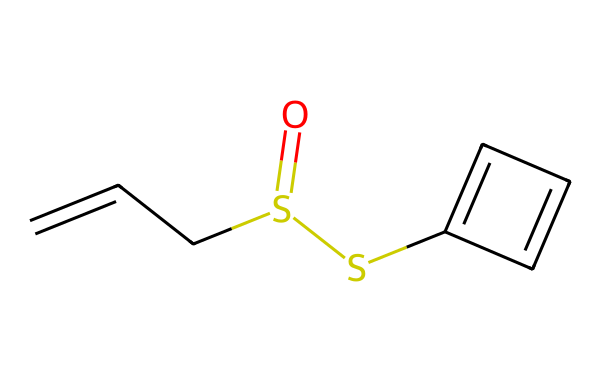What is the primary element in allicin's structure? The structural formula contains sulfur as a distinctive element, which is central to the chemical's classification as a sulfur compound.
Answer: sulfur How many carbon atoms are present in allicin? By analyzing the structural representation and counting the carbon atoms in the chains and rings, there are six carbon atoms in total.
Answer: 6 What type of bond is primarily formed between the sulfur atoms in allicin? The presence of a single bond (-S-) between the two sulfur atoms indicates that they are connected by a single covalent bond.
Answer: single bond What does the presence of the double bond in allicin's structure indicate? The double bond found in the carbon chain (between carbon atoms) indicates that allicin has unsaturation, which is key for its chemical reactivity and characteristic aroma.
Answer: unsaturation Is allicin a saturated or unsaturated compound? Given the presence of double bonds between carbon atoms, allicin is classified as an unsaturated compound.
Answer: unsaturated What is the functional group present in allicin responsible for its characteristic aroma? The thioether group (-S-) present in allicin is responsible for the distinct aroma associated with garlic.
Answer: thioether How many total sulfur atoms are in allicin's structure? There are two sulfur atoms represented in the SMILES structure, indicating that allicin contains two occurrences of sulfur in its molecular framework.
Answer: 2 